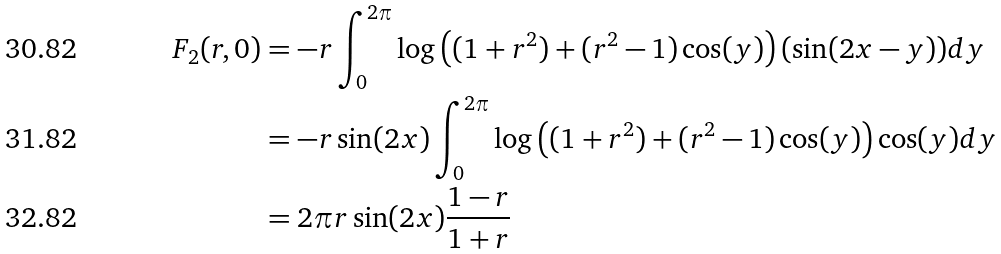Convert formula to latex. <formula><loc_0><loc_0><loc_500><loc_500>F _ { 2 } ( r , 0 ) & = - r \int _ { 0 } ^ { 2 \pi } \log \left ( ( 1 + r ^ { 2 } ) + ( r ^ { 2 } - 1 ) \cos ( y ) \right ) ( \sin ( 2 x - y ) ) d y \\ & = - r \sin ( 2 x ) \int _ { 0 } ^ { 2 \pi } \log \left ( ( 1 + r ^ { 2 } ) + ( r ^ { 2 } - 1 ) \cos ( y ) \right ) \cos ( y ) d y \\ & = 2 \pi r \sin ( 2 x ) \frac { 1 - r } { 1 + r }</formula> 